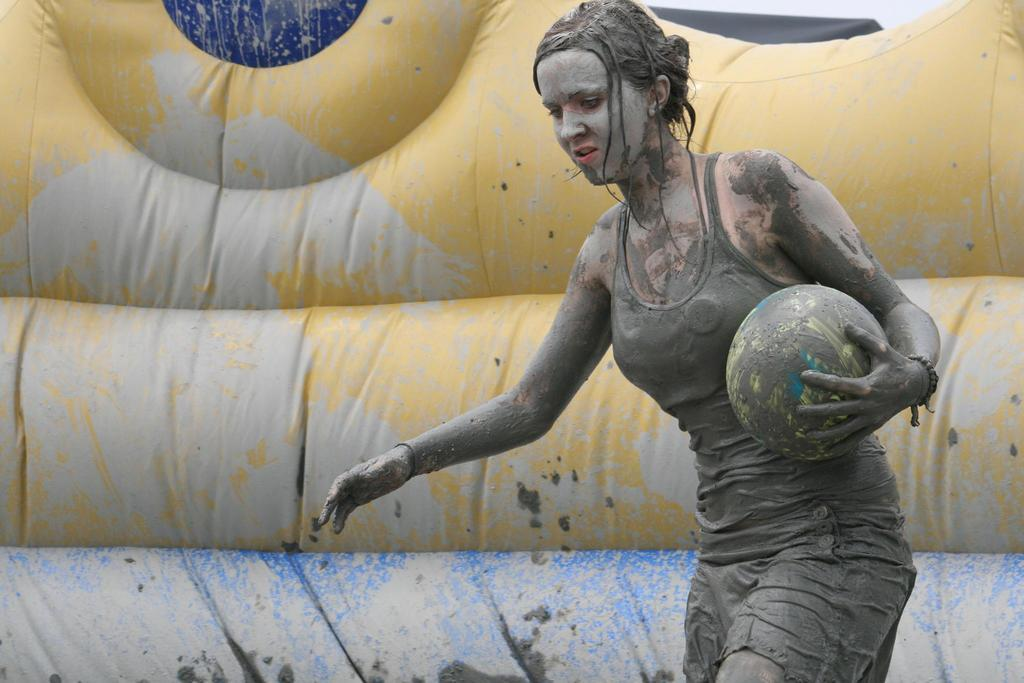Who is present in the image? There is a woman in the image. What is the woman holding? The woman is holding a ball. How does the woman's appearance look in the image? The woman's dress and face are covered in mud. What can be seen in the background of the image? There is a gas balloon in the background of the image. What type of soda is being served at the war in the image? There is no war or soda present in the image; it features a woman holding a ball and a gas balloon in the background. 